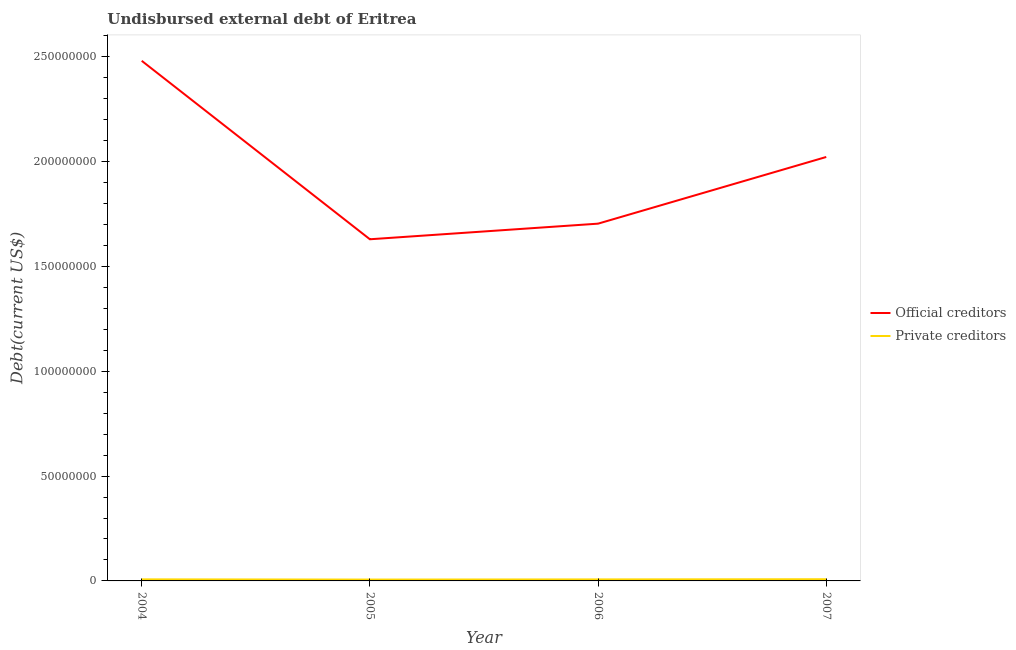What is the undisbursed external debt of official creditors in 2005?
Provide a succinct answer. 1.63e+08. Across all years, what is the maximum undisbursed external debt of official creditors?
Provide a succinct answer. 2.48e+08. Across all years, what is the minimum undisbursed external debt of official creditors?
Your answer should be very brief. 1.63e+08. In which year was the undisbursed external debt of official creditors maximum?
Keep it short and to the point. 2004. In which year was the undisbursed external debt of private creditors minimum?
Make the answer very short. 2005. What is the total undisbursed external debt of private creditors in the graph?
Keep it short and to the point. 2.93e+06. What is the difference between the undisbursed external debt of private creditors in 2006 and that in 2007?
Offer a very short reply. -8.50e+04. What is the difference between the undisbursed external debt of official creditors in 2004 and the undisbursed external debt of private creditors in 2006?
Keep it short and to the point. 2.47e+08. What is the average undisbursed external debt of private creditors per year?
Offer a very short reply. 7.32e+05. In the year 2007, what is the difference between the undisbursed external debt of official creditors and undisbursed external debt of private creditors?
Offer a terse response. 2.01e+08. In how many years, is the undisbursed external debt of official creditors greater than 70000000 US$?
Your answer should be very brief. 4. What is the ratio of the undisbursed external debt of official creditors in 2006 to that in 2007?
Make the answer very short. 0.84. Is the difference between the undisbursed external debt of private creditors in 2004 and 2005 greater than the difference between the undisbursed external debt of official creditors in 2004 and 2005?
Offer a very short reply. No. What is the difference between the highest and the lowest undisbursed external debt of official creditors?
Make the answer very short. 8.51e+07. Is the sum of the undisbursed external debt of official creditors in 2006 and 2007 greater than the maximum undisbursed external debt of private creditors across all years?
Your answer should be very brief. Yes. Does the undisbursed external debt of private creditors monotonically increase over the years?
Keep it short and to the point. No. How many lines are there?
Make the answer very short. 2. How many years are there in the graph?
Give a very brief answer. 4. What is the difference between two consecutive major ticks on the Y-axis?
Give a very brief answer. 5.00e+07. Are the values on the major ticks of Y-axis written in scientific E-notation?
Provide a succinct answer. No. Does the graph contain any zero values?
Provide a succinct answer. No. Where does the legend appear in the graph?
Offer a very short reply. Center right. How many legend labels are there?
Provide a short and direct response. 2. How are the legend labels stacked?
Provide a succinct answer. Vertical. What is the title of the graph?
Your answer should be compact. Undisbursed external debt of Eritrea. Does "Foreign liabilities" appear as one of the legend labels in the graph?
Make the answer very short. No. What is the label or title of the X-axis?
Offer a very short reply. Year. What is the label or title of the Y-axis?
Offer a terse response. Debt(current US$). What is the Debt(current US$) of Official creditors in 2004?
Offer a very short reply. 2.48e+08. What is the Debt(current US$) of Private creditors in 2004?
Your response must be concise. 7.48e+05. What is the Debt(current US$) in Official creditors in 2005?
Your response must be concise. 1.63e+08. What is the Debt(current US$) of Private creditors in 2005?
Give a very brief answer. 6.48e+05. What is the Debt(current US$) in Official creditors in 2006?
Make the answer very short. 1.70e+08. What is the Debt(current US$) in Private creditors in 2006?
Give a very brief answer. 7.23e+05. What is the Debt(current US$) in Official creditors in 2007?
Offer a terse response. 2.02e+08. What is the Debt(current US$) of Private creditors in 2007?
Provide a succinct answer. 8.08e+05. Across all years, what is the maximum Debt(current US$) in Official creditors?
Keep it short and to the point. 2.48e+08. Across all years, what is the maximum Debt(current US$) in Private creditors?
Provide a short and direct response. 8.08e+05. Across all years, what is the minimum Debt(current US$) in Official creditors?
Ensure brevity in your answer.  1.63e+08. Across all years, what is the minimum Debt(current US$) of Private creditors?
Your answer should be compact. 6.48e+05. What is the total Debt(current US$) in Official creditors in the graph?
Offer a very short reply. 7.84e+08. What is the total Debt(current US$) in Private creditors in the graph?
Your answer should be very brief. 2.93e+06. What is the difference between the Debt(current US$) in Official creditors in 2004 and that in 2005?
Provide a short and direct response. 8.51e+07. What is the difference between the Debt(current US$) of Official creditors in 2004 and that in 2006?
Offer a terse response. 7.77e+07. What is the difference between the Debt(current US$) in Private creditors in 2004 and that in 2006?
Your answer should be compact. 2.50e+04. What is the difference between the Debt(current US$) of Official creditors in 2004 and that in 2007?
Your answer should be very brief. 4.59e+07. What is the difference between the Debt(current US$) in Official creditors in 2005 and that in 2006?
Keep it short and to the point. -7.45e+06. What is the difference between the Debt(current US$) of Private creditors in 2005 and that in 2006?
Make the answer very short. -7.50e+04. What is the difference between the Debt(current US$) in Official creditors in 2005 and that in 2007?
Give a very brief answer. -3.93e+07. What is the difference between the Debt(current US$) of Official creditors in 2006 and that in 2007?
Your answer should be very brief. -3.18e+07. What is the difference between the Debt(current US$) in Private creditors in 2006 and that in 2007?
Ensure brevity in your answer.  -8.50e+04. What is the difference between the Debt(current US$) in Official creditors in 2004 and the Debt(current US$) in Private creditors in 2005?
Your answer should be very brief. 2.47e+08. What is the difference between the Debt(current US$) of Official creditors in 2004 and the Debt(current US$) of Private creditors in 2006?
Your answer should be compact. 2.47e+08. What is the difference between the Debt(current US$) of Official creditors in 2004 and the Debt(current US$) of Private creditors in 2007?
Offer a very short reply. 2.47e+08. What is the difference between the Debt(current US$) of Official creditors in 2005 and the Debt(current US$) of Private creditors in 2006?
Make the answer very short. 1.62e+08. What is the difference between the Debt(current US$) of Official creditors in 2005 and the Debt(current US$) of Private creditors in 2007?
Your answer should be compact. 1.62e+08. What is the difference between the Debt(current US$) in Official creditors in 2006 and the Debt(current US$) in Private creditors in 2007?
Provide a short and direct response. 1.70e+08. What is the average Debt(current US$) of Official creditors per year?
Your answer should be compact. 1.96e+08. What is the average Debt(current US$) in Private creditors per year?
Your answer should be compact. 7.32e+05. In the year 2004, what is the difference between the Debt(current US$) of Official creditors and Debt(current US$) of Private creditors?
Make the answer very short. 2.47e+08. In the year 2005, what is the difference between the Debt(current US$) of Official creditors and Debt(current US$) of Private creditors?
Provide a succinct answer. 1.62e+08. In the year 2006, what is the difference between the Debt(current US$) in Official creditors and Debt(current US$) in Private creditors?
Offer a terse response. 1.70e+08. In the year 2007, what is the difference between the Debt(current US$) in Official creditors and Debt(current US$) in Private creditors?
Offer a terse response. 2.01e+08. What is the ratio of the Debt(current US$) in Official creditors in 2004 to that in 2005?
Ensure brevity in your answer.  1.52. What is the ratio of the Debt(current US$) in Private creditors in 2004 to that in 2005?
Offer a very short reply. 1.15. What is the ratio of the Debt(current US$) in Official creditors in 2004 to that in 2006?
Ensure brevity in your answer.  1.46. What is the ratio of the Debt(current US$) in Private creditors in 2004 to that in 2006?
Keep it short and to the point. 1.03. What is the ratio of the Debt(current US$) of Official creditors in 2004 to that in 2007?
Offer a very short reply. 1.23. What is the ratio of the Debt(current US$) in Private creditors in 2004 to that in 2007?
Provide a succinct answer. 0.93. What is the ratio of the Debt(current US$) of Official creditors in 2005 to that in 2006?
Ensure brevity in your answer.  0.96. What is the ratio of the Debt(current US$) in Private creditors in 2005 to that in 2006?
Offer a very short reply. 0.9. What is the ratio of the Debt(current US$) of Official creditors in 2005 to that in 2007?
Provide a short and direct response. 0.81. What is the ratio of the Debt(current US$) of Private creditors in 2005 to that in 2007?
Give a very brief answer. 0.8. What is the ratio of the Debt(current US$) of Official creditors in 2006 to that in 2007?
Offer a terse response. 0.84. What is the ratio of the Debt(current US$) of Private creditors in 2006 to that in 2007?
Make the answer very short. 0.89. What is the difference between the highest and the second highest Debt(current US$) in Official creditors?
Provide a succinct answer. 4.59e+07. What is the difference between the highest and the lowest Debt(current US$) in Official creditors?
Offer a very short reply. 8.51e+07. 